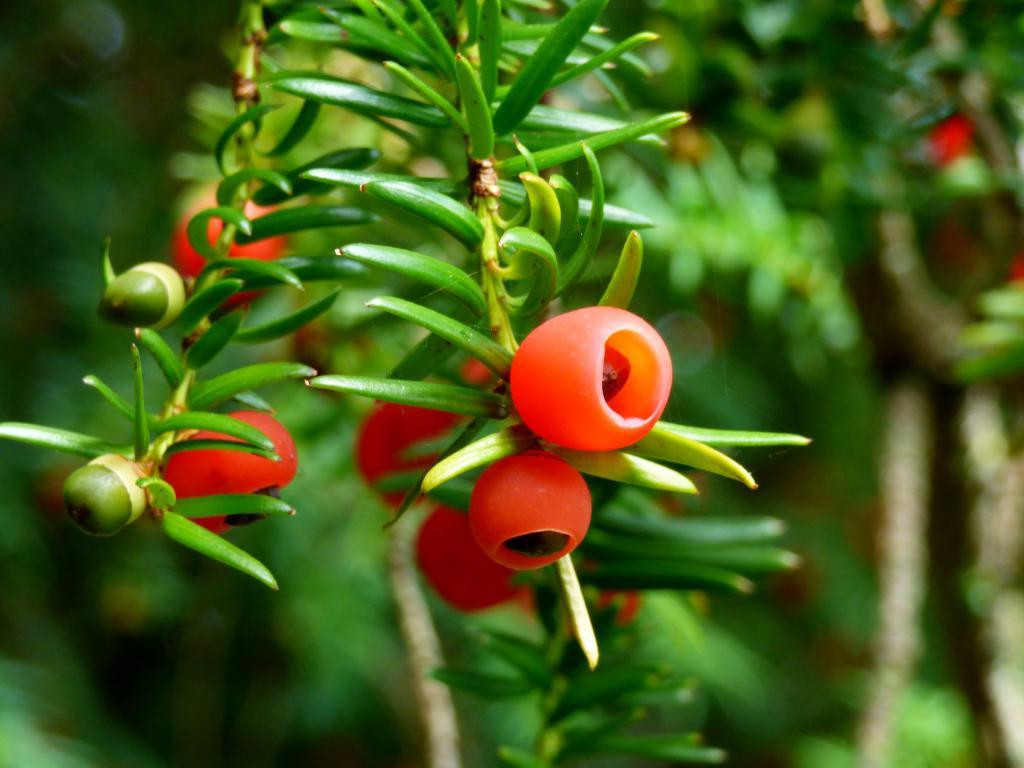What is present on the stem of the plant in the image? There are fruits on the stem of a plant in the image. What can be seen in the background of the image? There are many plants visible in the background of the image. What type of bone can be seen in the image? There is no bone present in the image; it features fruits on the stem of a plant and many plants in the background. 